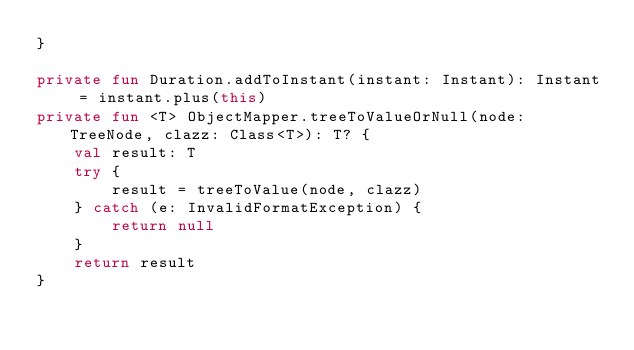Convert code to text. <code><loc_0><loc_0><loc_500><loc_500><_Kotlin_>}

private fun Duration.addToInstant(instant: Instant): Instant = instant.plus(this)
private fun <T> ObjectMapper.treeToValueOrNull(node: TreeNode, clazz: Class<T>): T? {
    val result: T
    try {
        result = treeToValue(node, clazz)
    } catch (e: InvalidFormatException) {
        return null
    }
    return result
}
</code> 